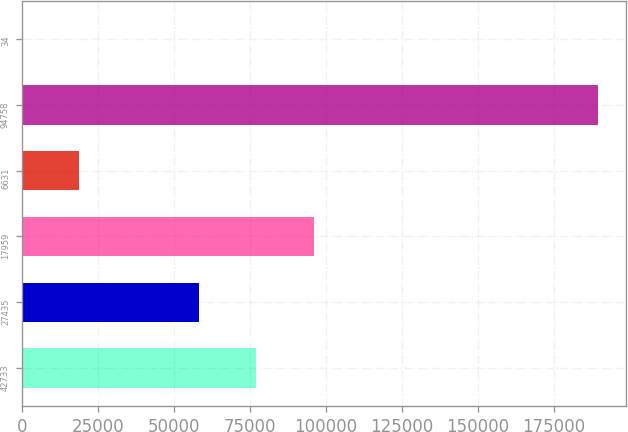<chart> <loc_0><loc_0><loc_500><loc_500><bar_chart><fcel>42733<fcel>27435<fcel>17959<fcel>6631<fcel>94758<fcel>34<nl><fcel>77171.2<fcel>58250<fcel>96092.4<fcel>18988.2<fcel>189279<fcel>67<nl></chart> 